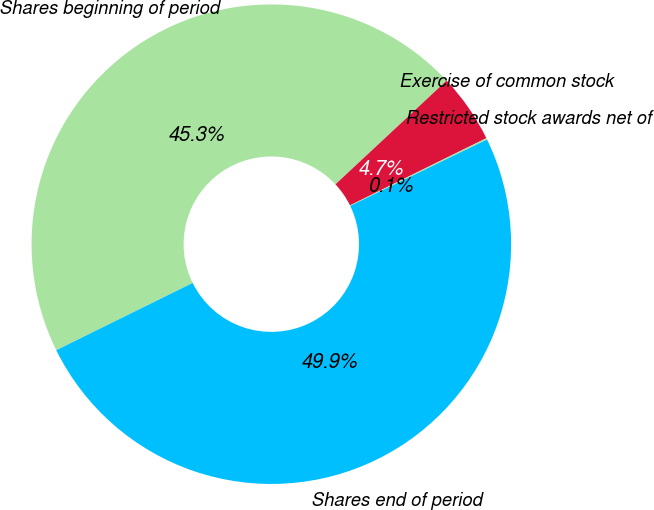Convert chart. <chart><loc_0><loc_0><loc_500><loc_500><pie_chart><fcel>Shares beginning of period<fcel>Exercise of common stock<fcel>Restricted stock awards net of<fcel>Shares end of period<nl><fcel>45.34%<fcel>4.66%<fcel>0.1%<fcel>49.9%<nl></chart> 